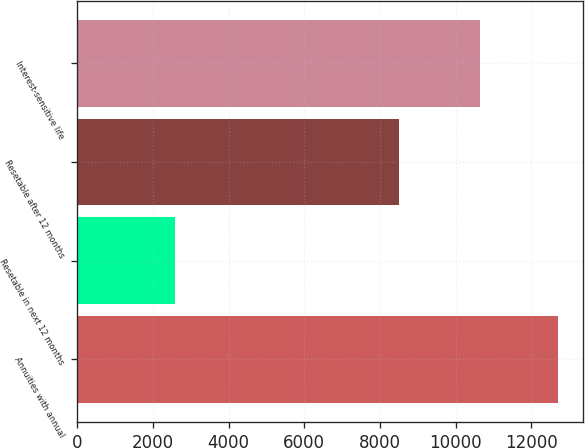Convert chart to OTSL. <chart><loc_0><loc_0><loc_500><loc_500><bar_chart><fcel>Annuities with annual<fcel>Resetable in next 12 months<fcel>Resetable after 12 months<fcel>Interest-sensitive life<nl><fcel>12718<fcel>2597<fcel>8503<fcel>10637<nl></chart> 